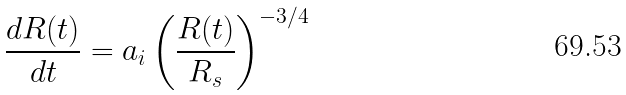<formula> <loc_0><loc_0><loc_500><loc_500>\frac { d R ( t ) } { d t } = a _ { i } \left ( \frac { R ( t ) } { R _ { s } } \right ) ^ { - 3 / 4 }</formula> 